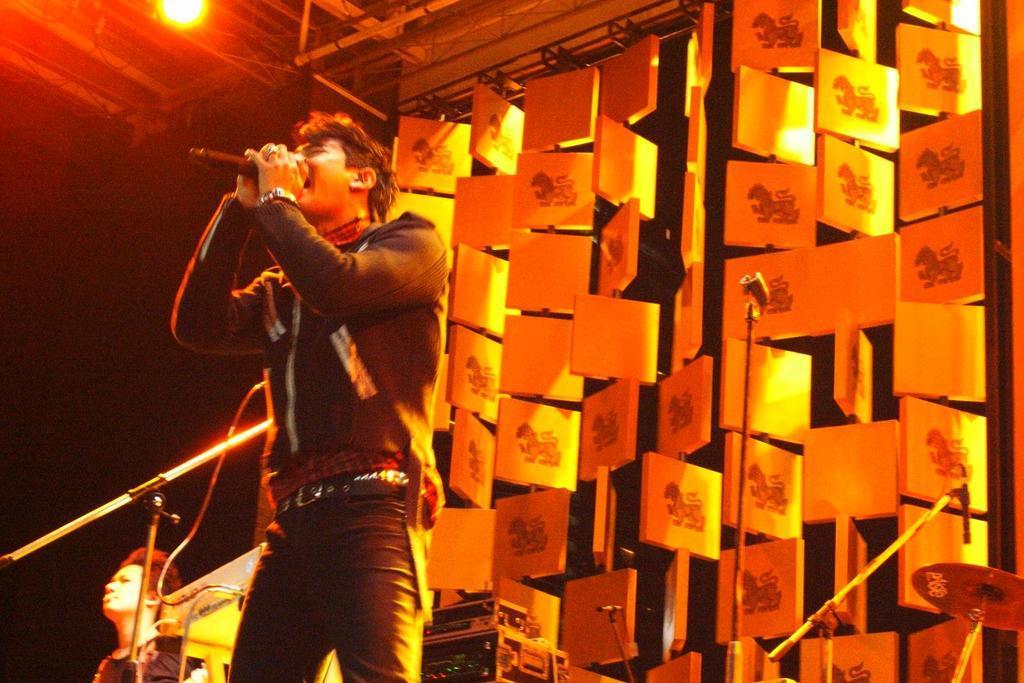Please provide a concise description of this image. In this picture I can see a person holding the microphone. I can see the musical instruments. I can see light arrangements on the roof. I can see a few objects in the background. I can see the face of a person in the bottom left hand corner. 